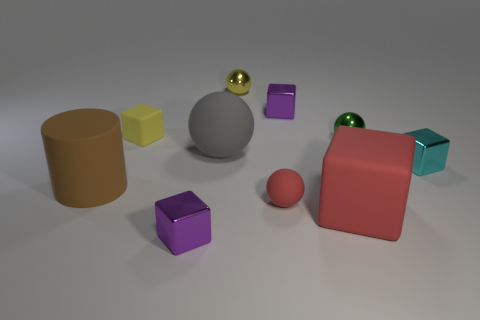Are there fewer blocks than big brown matte things?
Keep it short and to the point. No. There is a tiny rubber object that is on the right side of the yellow object that is on the left side of the purple object that is to the left of the big gray rubber thing; what shape is it?
Your answer should be compact. Sphere. Are there any large cylinders that have the same material as the large cube?
Your answer should be very brief. Yes. Does the tiny ball in front of the big matte cylinder have the same color as the big thing on the right side of the yellow ball?
Give a very brief answer. Yes. Are there fewer big gray objects that are right of the small yellow matte cube than tiny yellow metallic cubes?
Your answer should be very brief. No. How many things are either gray metal cylinders or objects that are in front of the tiny green thing?
Make the answer very short. 6. The large cylinder that is the same material as the tiny yellow cube is what color?
Ensure brevity in your answer.  Brown. How many things are either big cubes or tiny green metallic objects?
Your response must be concise. 2. What is the color of the rubber ball that is the same size as the red matte block?
Make the answer very short. Gray. How many things are purple shiny objects that are in front of the cyan object or blue metal spheres?
Your response must be concise. 1. 